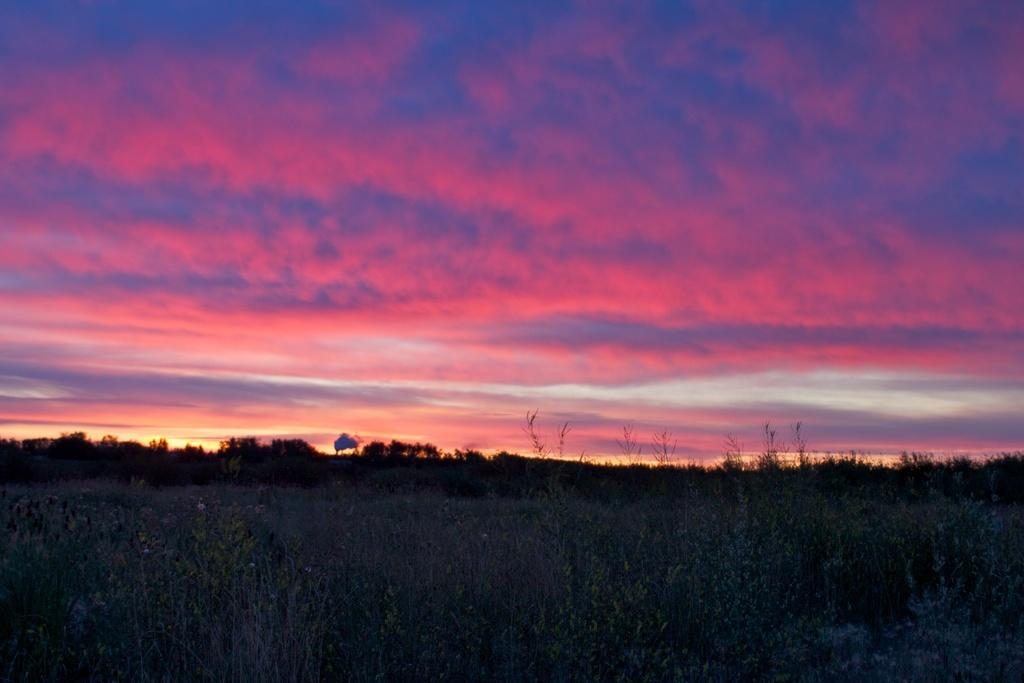What is located in the center of the image? There are trees in the center of the image. What can be found at the bottom of the image? There are plants at the bottom of the image. What is visible at the top of the image? There is a sunset visible at the top of the image. What else can be seen in the sky? Clouds are present in the sky. Can you tell me how many eggs are in the eggnog in the image? There is no eggnog present in the image, so it is not possible to determine the number of eggs in it. Does the existence of the trees in the image prove the existence of a parallel universe? The presence of trees in the image does not prove the existence of a parallel universe; it simply shows trees in the image. 